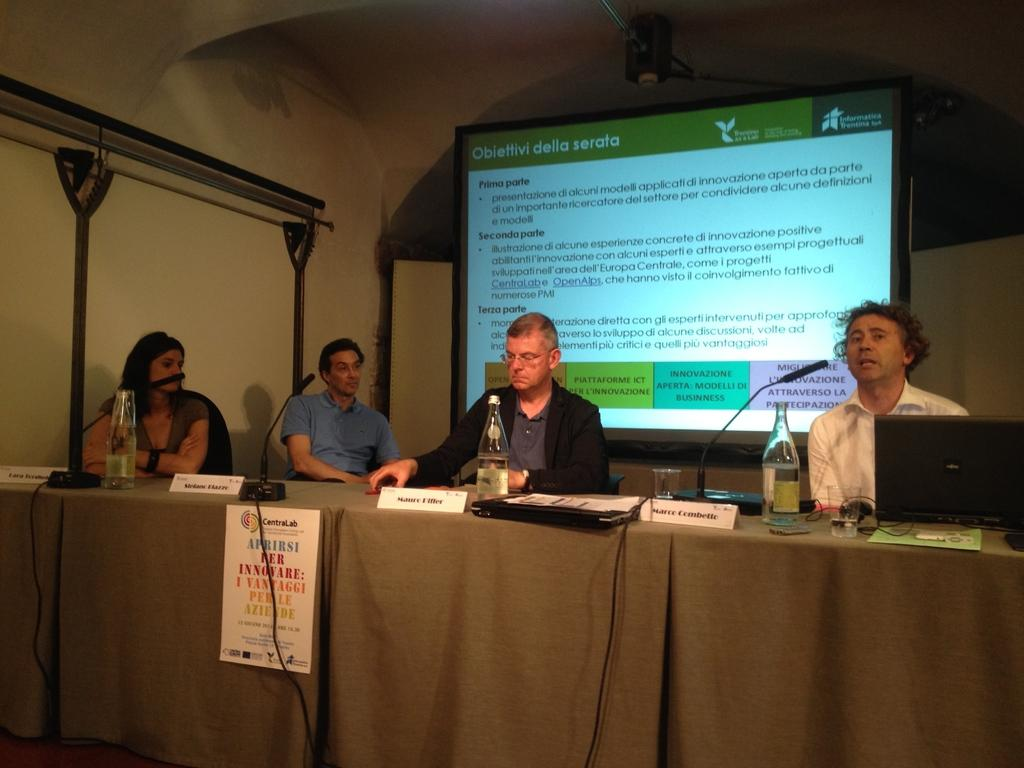How many people are sitting in the image? There are four persons sitting in the image. What objects can be seen on the table? There are bottles, glasses, and microphones on the table. What is located in the background of the image? There is a projection screen in the background. What type of yam is being served on the table in the image? There is no yam present in the image; the table contains bottles, glasses, and microphones. How many pickles are visible on the table in the image? There are no pickles visible on the table in the image. 